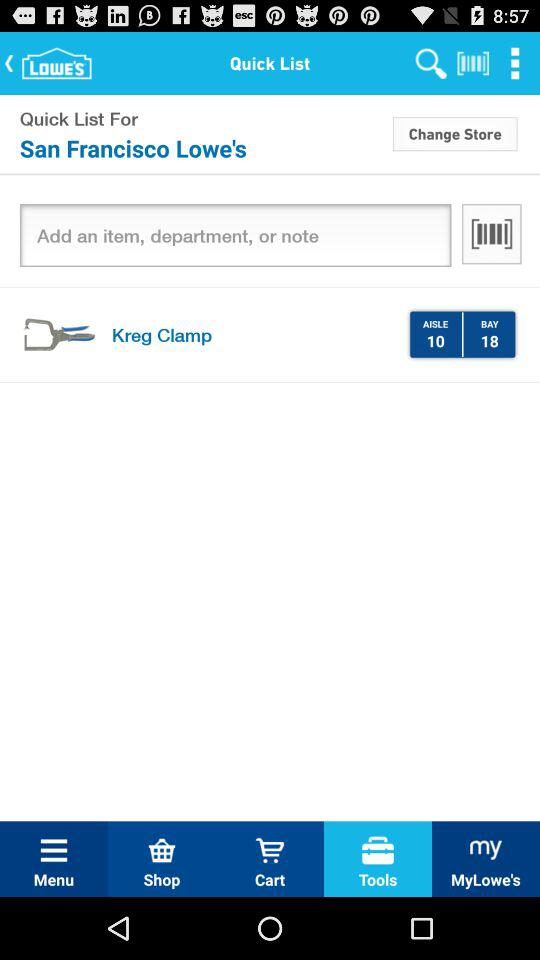What is the selected tab? The selected tab is "Tools". 